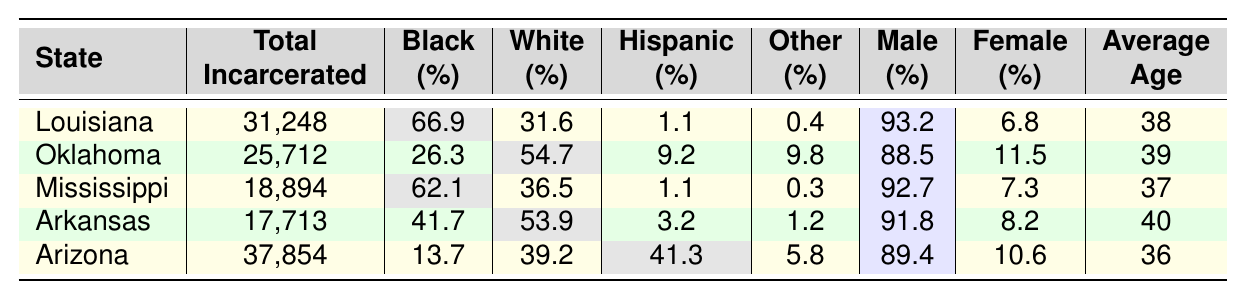What state has the highest total incarcerated population? By looking at the "Total Incarcerated" column, we see that Arizona has the highest value of 37,854.
Answer: Arizona What percentage of the incarcerated population in Louisiana is Black? In the "Black (%)" column for Louisiana, the value listed is 66.9%.
Answer: 66.9% Which state has the lowest percentage of Hispanic incarcerated individuals? In the "Hispanic (%)" column, we can see that Louisiana has the lowest percentage at 1.1%.
Answer: Louisiana How many incarcerated individuals in Arkansas are female? To find this, we take the total incarcerated number for Arkansas (17,713) and multiply it by the female percentage (8.2%). Thus, 17,713 * 0.082 = approximately 1,453.
Answer: 1,453 What is the average age of the incarcerated population in Mississippi? From the "Average Age" column for Mississippi, it is directly listed as 37.
Answer: 37 Does Oklahoma have a higher percentage of White incarcerated individuals compared to Louisiana? Looking at the "White (%)" column, Oklahoma has 54.7% while Louisiana has 31.6%. Therefore, Oklahoma does have a higher percentage.
Answer: Yes Which state has the largest gap between the percentage of Black and White incarcerated individuals? To find the gap for each state, we subtract the percentage of White from Black. The largest gap is in Louisiana: 66.9% - 31.6% = 35.3%.
Answer: Louisiana What is the total percentage of female incarcerated individuals across all listed states? We sum the female percentages for all states: 6.8 + 11.5 + 7.3 + 8.2 + 10.6 = 44.4%.
Answer: 44.4% Is the average age of the incarcerated population in Oklahoma higher than that in Mississippi? Oklahoma's average age is 39, while Mississippi's is 37, so Oklahoma's average age is higher.
Answer: Yes Which state has the highest percentage of male incarcerated individuals? In the "Male (%)" column, Louisiana shows the highest at 93.2%.
Answer: Louisiana 